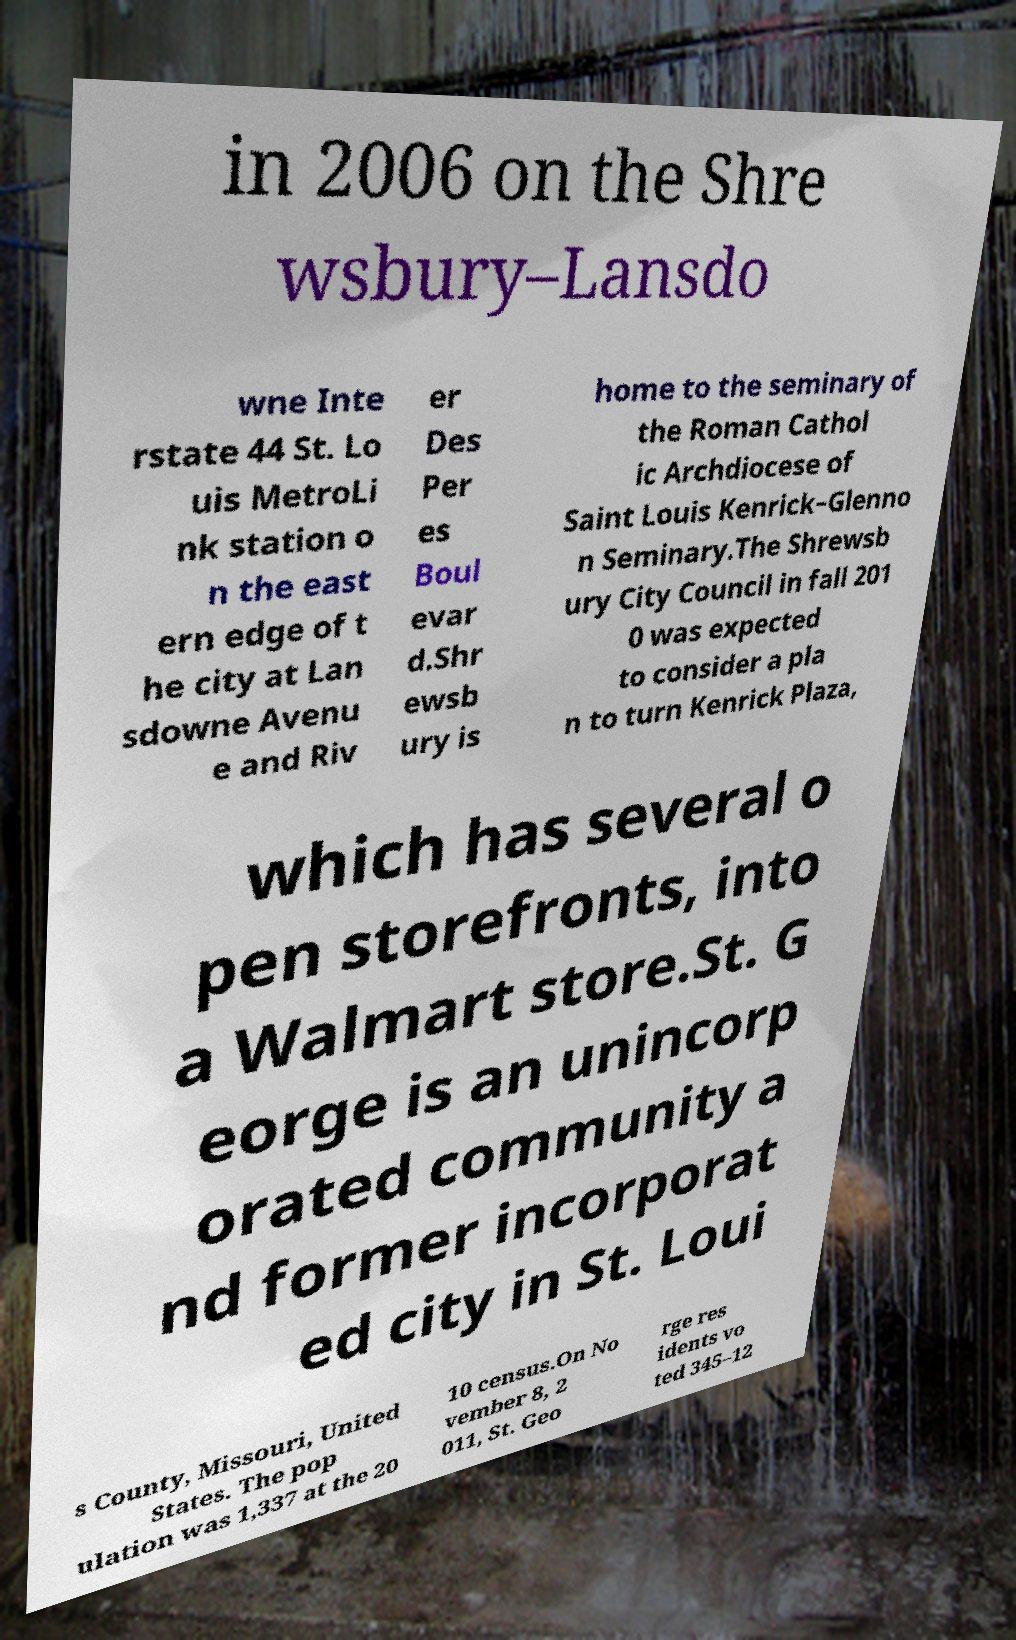For documentation purposes, I need the text within this image transcribed. Could you provide that? in 2006 on the Shre wsbury–Lansdo wne Inte rstate 44 St. Lo uis MetroLi nk station o n the east ern edge of t he city at Lan sdowne Avenu e and Riv er Des Per es Boul evar d.Shr ewsb ury is home to the seminary of the Roman Cathol ic Archdiocese of Saint Louis Kenrick–Glenno n Seminary.The Shrewsb ury City Council in fall 201 0 was expected to consider a pla n to turn Kenrick Plaza, which has several o pen storefronts, into a Walmart store.St. G eorge is an unincorp orated community a nd former incorporat ed city in St. Loui s County, Missouri, United States. The pop ulation was 1,337 at the 20 10 census.On No vember 8, 2 011, St. Geo rge res idents vo ted 345–12 